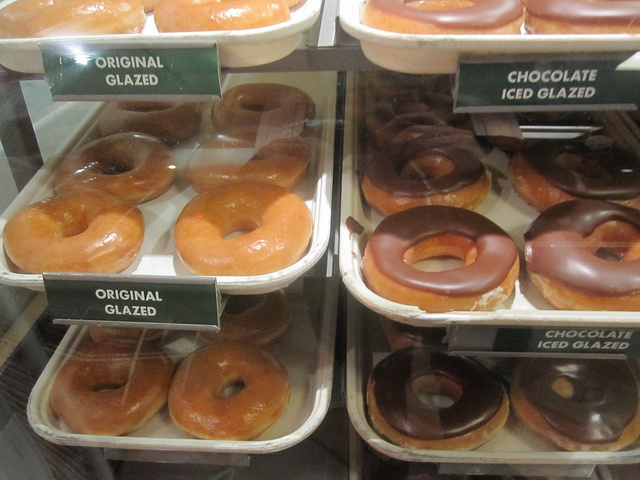Describe the objects in this image and their specific colors. I can see donut in darkgray, black, tan, and maroon tones, donut in darkgray, salmon, maroon, brown, and tan tones, donut in darkgray, brown, maroon, and tan tones, donut in darkgray, brown, maroon, and gray tones, and donut in darkgray, orange, red, and tan tones in this image. 